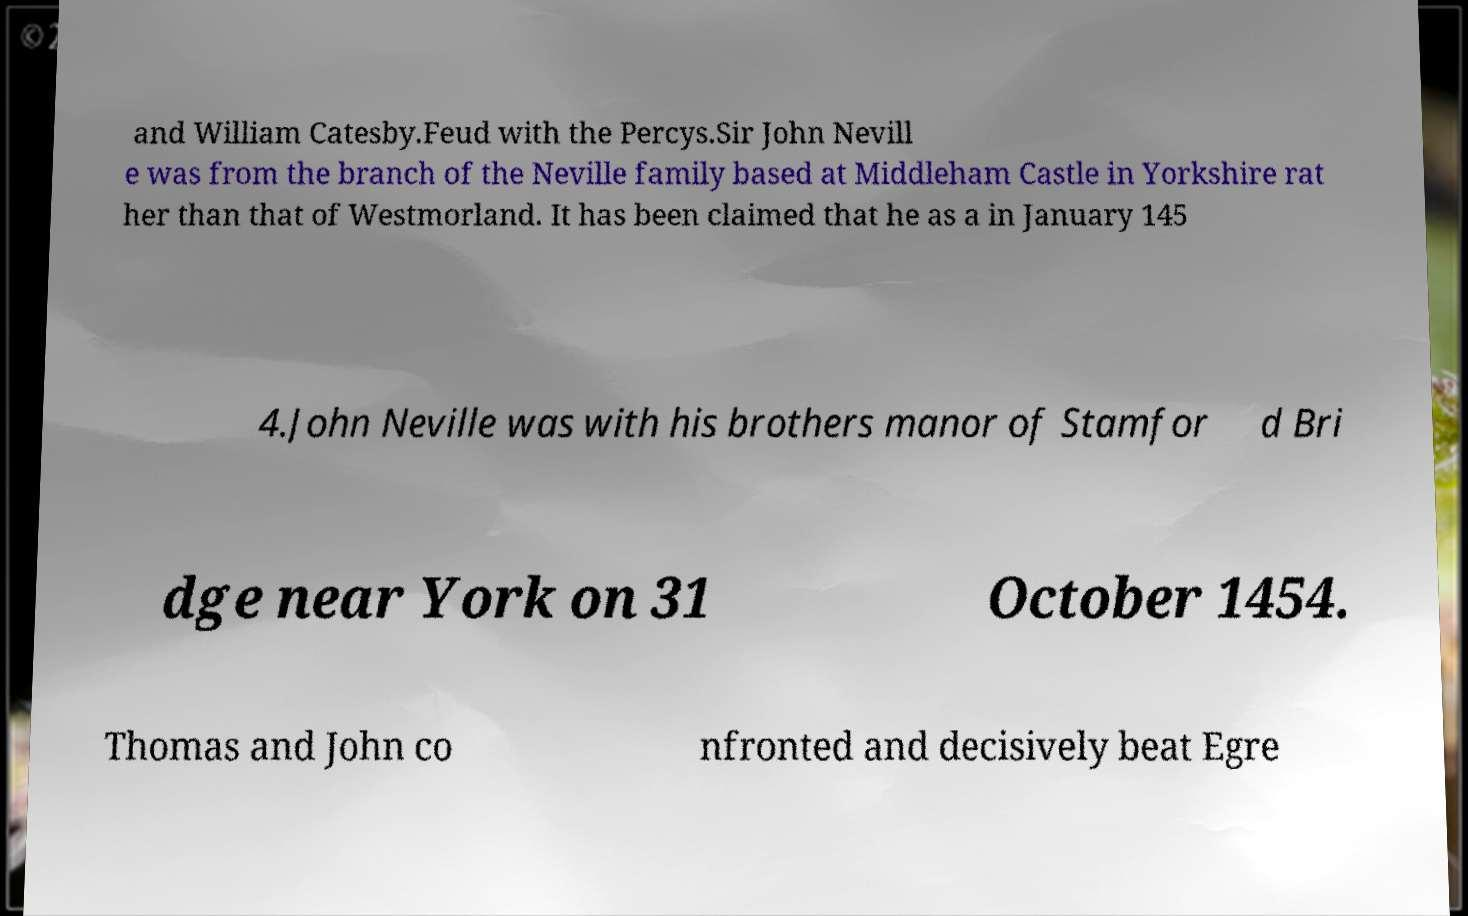Could you extract and type out the text from this image? and William Catesby.Feud with the Percys.Sir John Nevill e was from the branch of the Neville family based at Middleham Castle in Yorkshire rat her than that of Westmorland. It has been claimed that he as a in January 145 4.John Neville was with his brothers manor of Stamfor d Bri dge near York on 31 October 1454. Thomas and John co nfronted and decisively beat Egre 